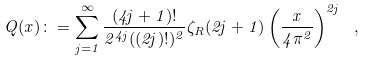Convert formula to latex. <formula><loc_0><loc_0><loc_500><loc_500>Q ( x ) \colon = \sum _ { j = 1 } ^ { \infty } \frac { ( 4 j + 1 ) ! } { 2 ^ { 4 j } ( ( 2 j ) ! ) ^ { 2 } } \zeta _ { R } ( 2 j + 1 ) \left ( \frac { x } { 4 \pi ^ { 2 } } \right ) ^ { 2 j } \ ,</formula> 